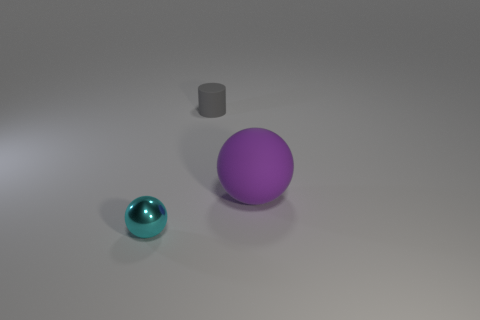Add 1 big purple rubber balls. How many objects exist? 4 Subtract all purple spheres. How many spheres are left? 1 Subtract all cylinders. How many objects are left? 2 Subtract 0 green cubes. How many objects are left? 3 Subtract all purple cylinders. Subtract all blue blocks. How many cylinders are left? 1 Subtract all big purple balls. Subtract all tiny yellow matte cylinders. How many objects are left? 2 Add 3 big rubber things. How many big rubber things are left? 4 Add 2 tiny yellow matte cylinders. How many tiny yellow matte cylinders exist? 2 